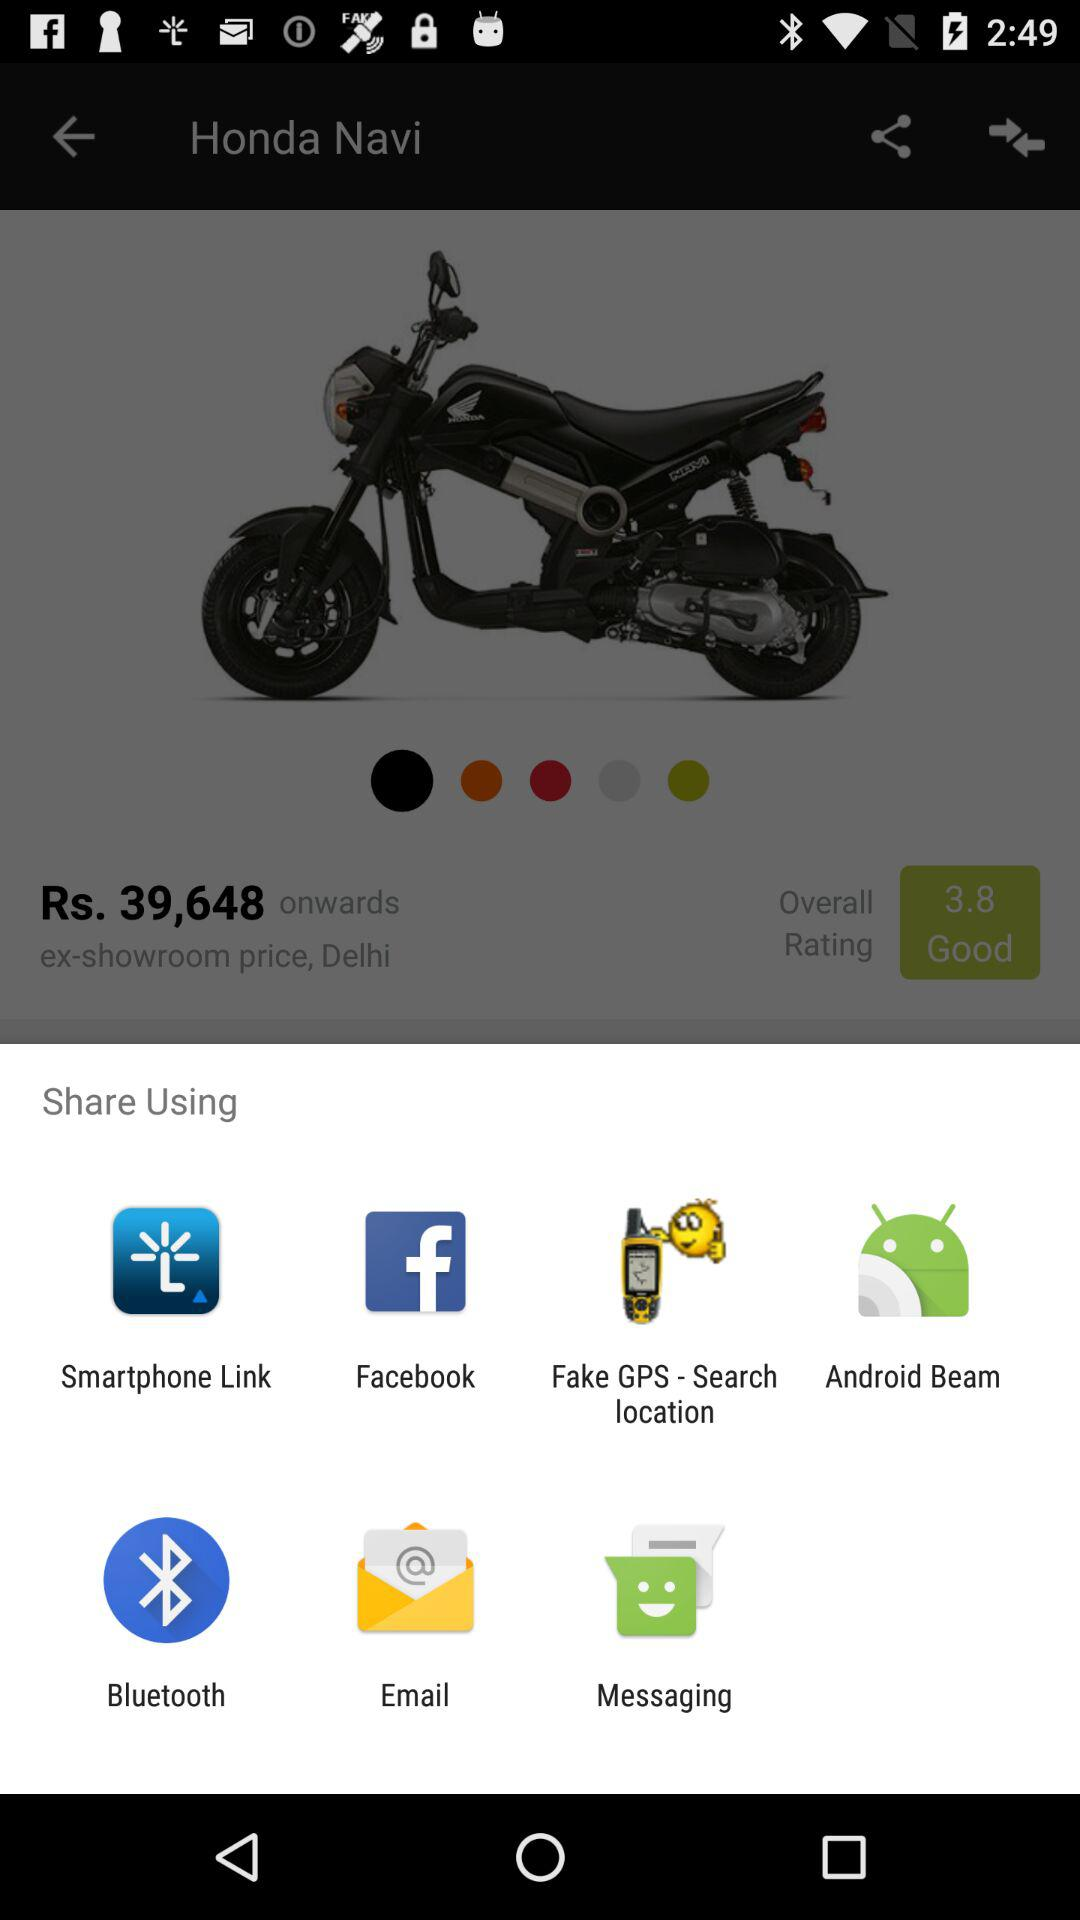What is the starting price of the "Honda Navi"? The starting price is Rs. 39,648. 